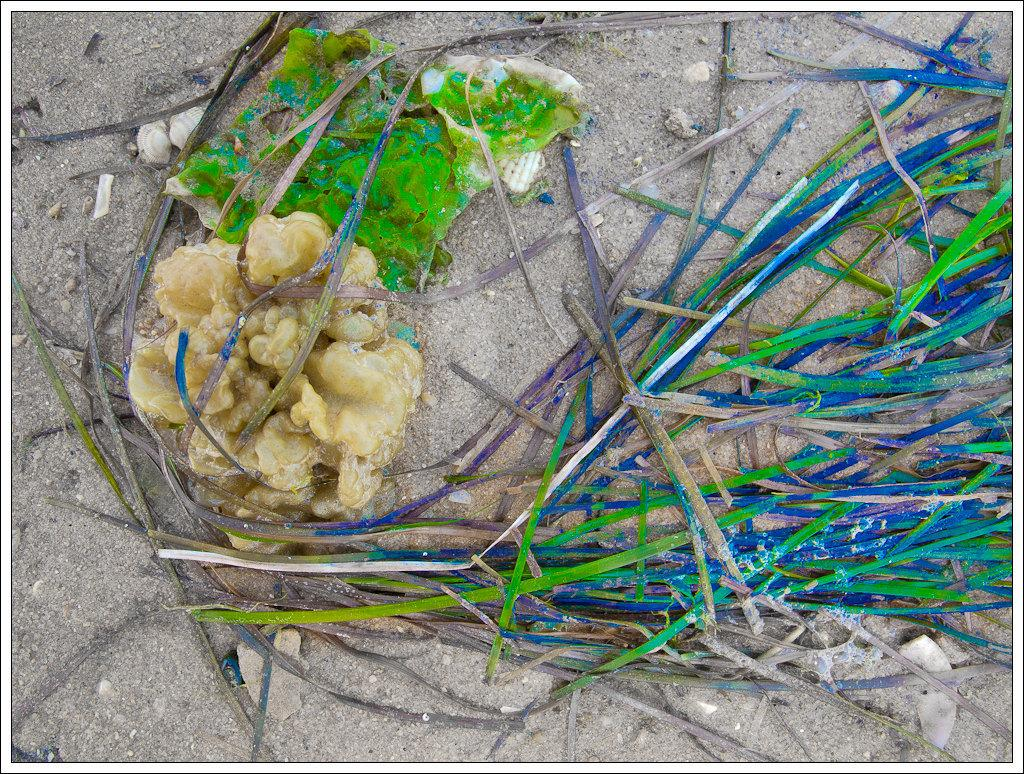What type of natural formation can be seen in the image? There are coral in the image. What other items are present in the image? There are shells in the image. What colors are featured in the items in the image? The items in the image are in green, blue, and white colors. On what surface are these items located? All these items are on the sand. Can you see any gloves in the image? There are no gloves present in the image. Are there any ants crawling on the coral in the image? There is no mention of ants in the image, so it cannot be determined if any are present. 